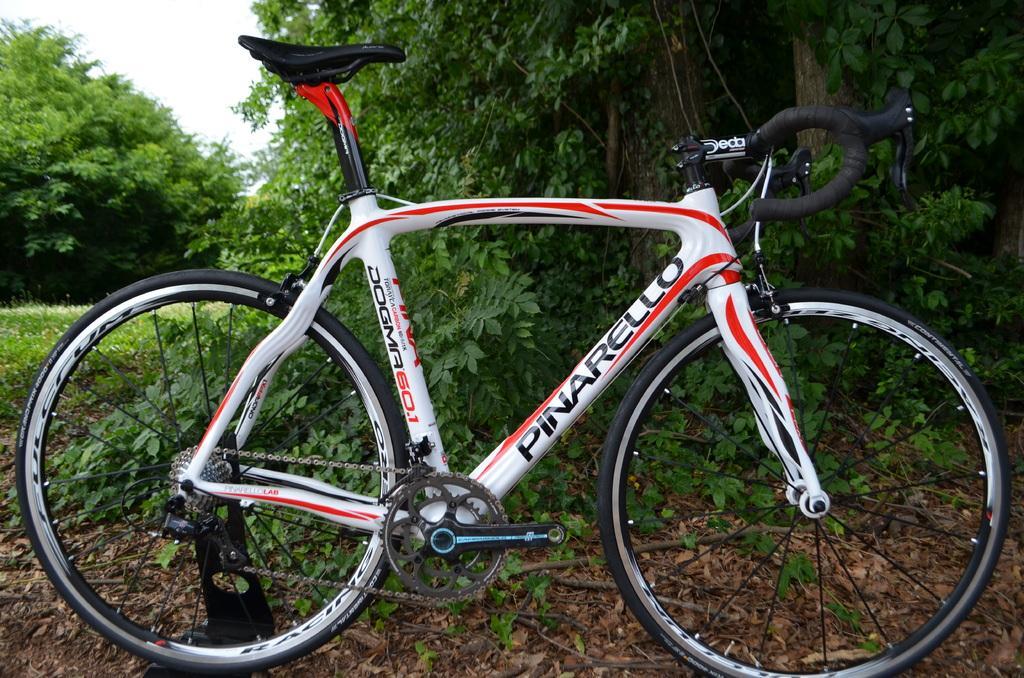How would you summarize this image in a sentence or two? This image is taken outdoors. At the top of the image there is the sky. In the background there are many trees and plants with leaves, stems and branches. At the bottom of the image there is a ground with many dry leaves on it. In the middle of the image a bicycle is parked on the ground. 